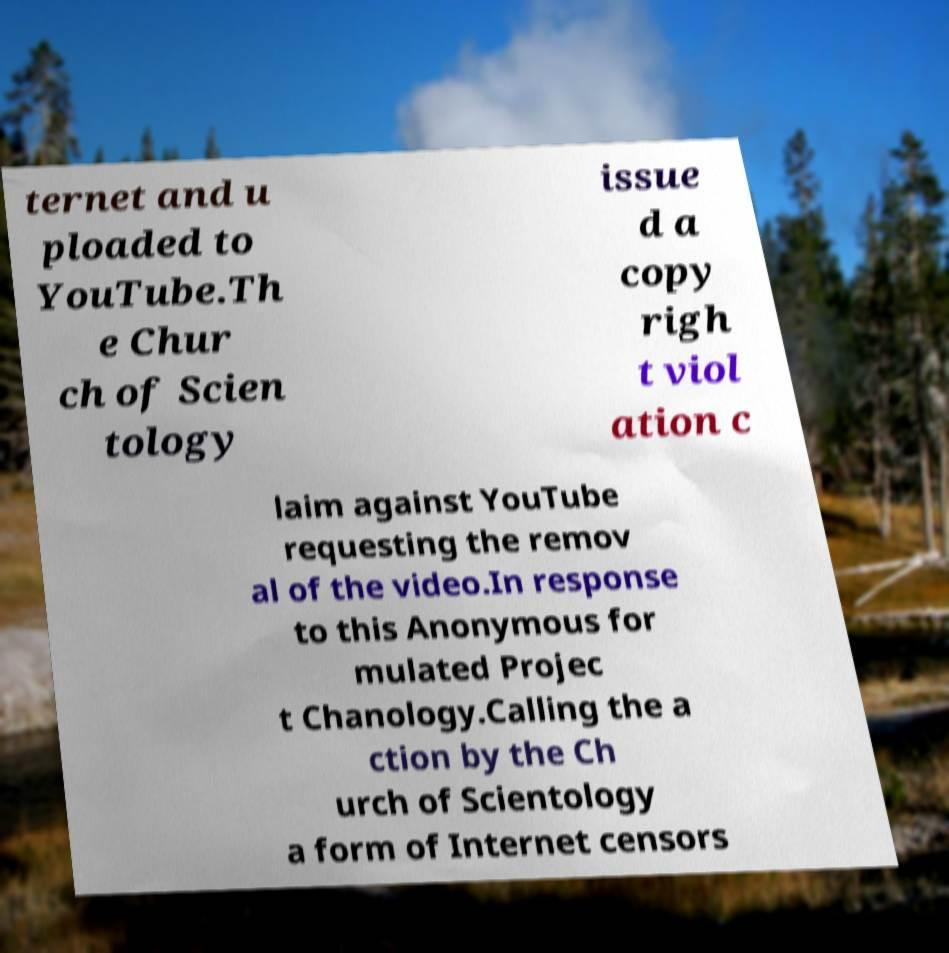For documentation purposes, I need the text within this image transcribed. Could you provide that? ternet and u ploaded to YouTube.Th e Chur ch of Scien tology issue d a copy righ t viol ation c laim against YouTube requesting the remov al of the video.In response to this Anonymous for mulated Projec t Chanology.Calling the a ction by the Ch urch of Scientology a form of Internet censors 